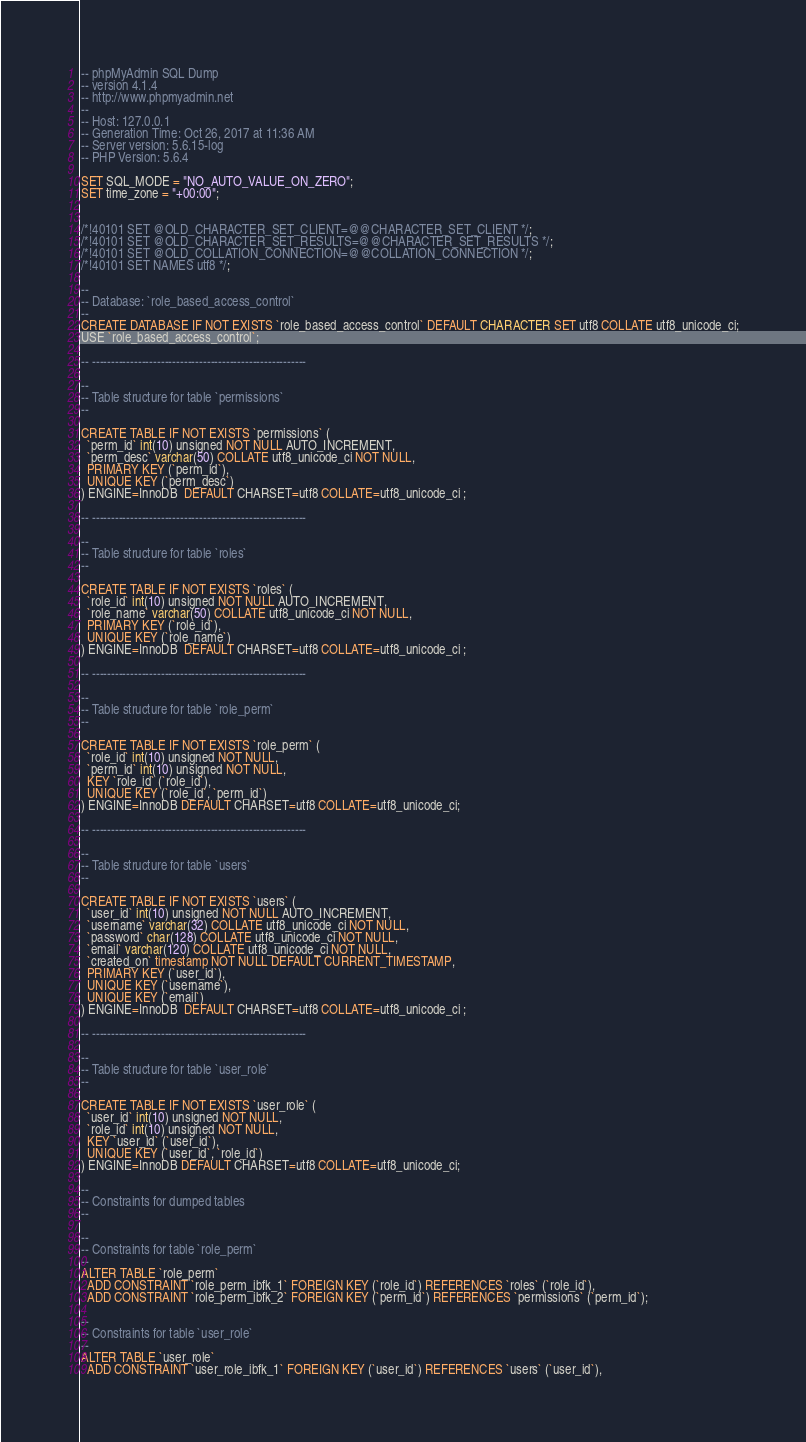Convert code to text. <code><loc_0><loc_0><loc_500><loc_500><_SQL_>-- phpMyAdmin SQL Dump
-- version 4.1.4
-- http://www.phpmyadmin.net
--
-- Host: 127.0.0.1
-- Generation Time: Oct 26, 2017 at 11:36 AM
-- Server version: 5.6.15-log
-- PHP Version: 5.6.4

SET SQL_MODE = "NO_AUTO_VALUE_ON_ZERO";
SET time_zone = "+00:00";


/*!40101 SET @OLD_CHARACTER_SET_CLIENT=@@CHARACTER_SET_CLIENT */;
/*!40101 SET @OLD_CHARACTER_SET_RESULTS=@@CHARACTER_SET_RESULTS */;
/*!40101 SET @OLD_COLLATION_CONNECTION=@@COLLATION_CONNECTION */;
/*!40101 SET NAMES utf8 */;

--
-- Database: `role_based_access_control`
--
CREATE DATABASE IF NOT EXISTS `role_based_access_control` DEFAULT CHARACTER SET utf8 COLLATE utf8_unicode_ci;
USE `role_based_access_control`;

-- --------------------------------------------------------

--
-- Table structure for table `permissions`
--

CREATE TABLE IF NOT EXISTS `permissions` (
  `perm_id` int(10) unsigned NOT NULL AUTO_INCREMENT,
  `perm_desc` varchar(50) COLLATE utf8_unicode_ci NOT NULL,
  PRIMARY KEY (`perm_id`),
  UNIQUE KEY (`perm_desc`)
) ENGINE=InnoDB  DEFAULT CHARSET=utf8 COLLATE=utf8_unicode_ci ;

-- --------------------------------------------------------

--
-- Table structure for table `roles`
--

CREATE TABLE IF NOT EXISTS `roles` (
  `role_id` int(10) unsigned NOT NULL AUTO_INCREMENT,
  `role_name` varchar(50) COLLATE utf8_unicode_ci NOT NULL,
  PRIMARY KEY (`role_id`),
  UNIQUE KEY (`role_name`)
) ENGINE=InnoDB  DEFAULT CHARSET=utf8 COLLATE=utf8_unicode_ci ;

-- --------------------------------------------------------

--
-- Table structure for table `role_perm`
--

CREATE TABLE IF NOT EXISTS `role_perm` (
  `role_id` int(10) unsigned NOT NULL,
  `perm_id` int(10) unsigned NOT NULL,
  KEY `role_id` (`role_id`),
  UNIQUE KEY (`role_id`, `perm_id`)
) ENGINE=InnoDB DEFAULT CHARSET=utf8 COLLATE=utf8_unicode_ci;

-- --------------------------------------------------------

--
-- Table structure for table `users`
--

CREATE TABLE IF NOT EXISTS `users` (
  `user_id` int(10) unsigned NOT NULL AUTO_INCREMENT,
  `username` varchar(32) COLLATE utf8_unicode_ci NOT NULL,
  `password` char(128) COLLATE utf8_unicode_ci NOT NULL,
  `email` varchar(120) COLLATE utf8_unicode_ci NOT NULL,
  `created_on` timestamp NOT NULL DEFAULT CURRENT_TIMESTAMP,
  PRIMARY KEY (`user_id`),
  UNIQUE KEY (`username`),
  UNIQUE KEY (`email`)
) ENGINE=InnoDB  DEFAULT CHARSET=utf8 COLLATE=utf8_unicode_ci ;

-- --------------------------------------------------------

--
-- Table structure for table `user_role`
--

CREATE TABLE IF NOT EXISTS `user_role` (
  `user_id` int(10) unsigned NOT NULL,
  `role_id` int(10) unsigned NOT NULL,
  KEY `user_id` (`user_id`),
  UNIQUE KEY (`user_id`, `role_id`)
) ENGINE=InnoDB DEFAULT CHARSET=utf8 COLLATE=utf8_unicode_ci;

--
-- Constraints for dumped tables
--

--
-- Constraints for table `role_perm`
--
ALTER TABLE `role_perm`
  ADD CONSTRAINT `role_perm_ibfk_1` FOREIGN KEY (`role_id`) REFERENCES `roles` (`role_id`),
  ADD CONSTRAINT `role_perm_ibfk_2` FOREIGN KEY (`perm_id`) REFERENCES `permissions` (`perm_id`);

--
-- Constraints for table `user_role`
--
ALTER TABLE `user_role`
  ADD CONSTRAINT `user_role_ibfk_1` FOREIGN KEY (`user_id`) REFERENCES `users` (`user_id`),</code> 